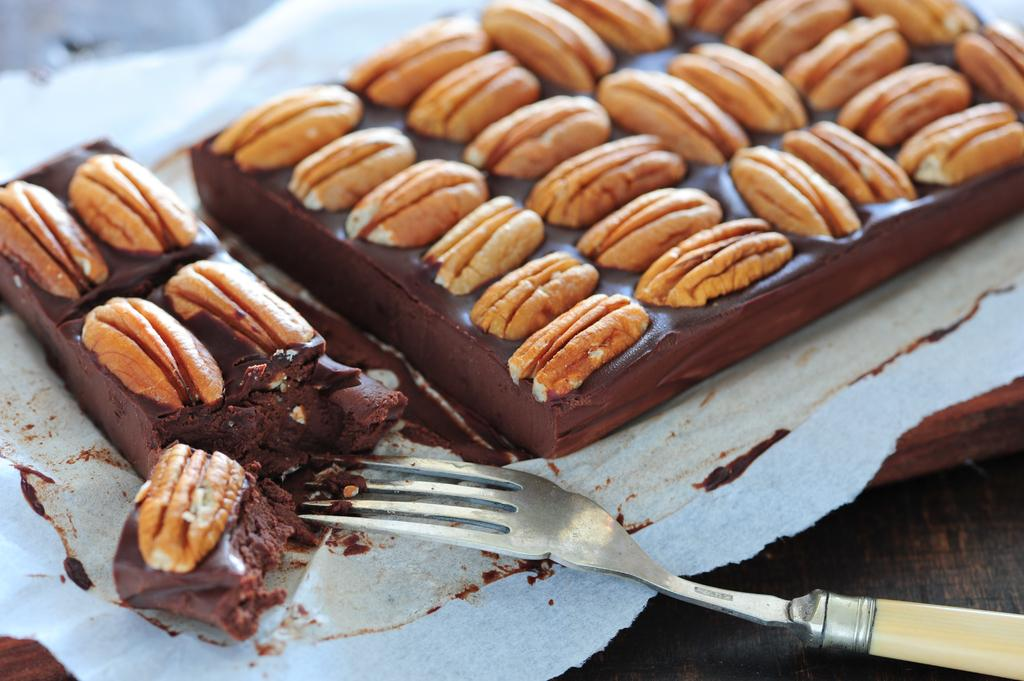What type of food is present in the image? There are chocolates in the image. What utensil can be seen in the image? There is a fork in the image. What type of voice can be heard coming from the chocolates in the image? There is no voice coming from the chocolates in the image, as they are inanimate objects. 